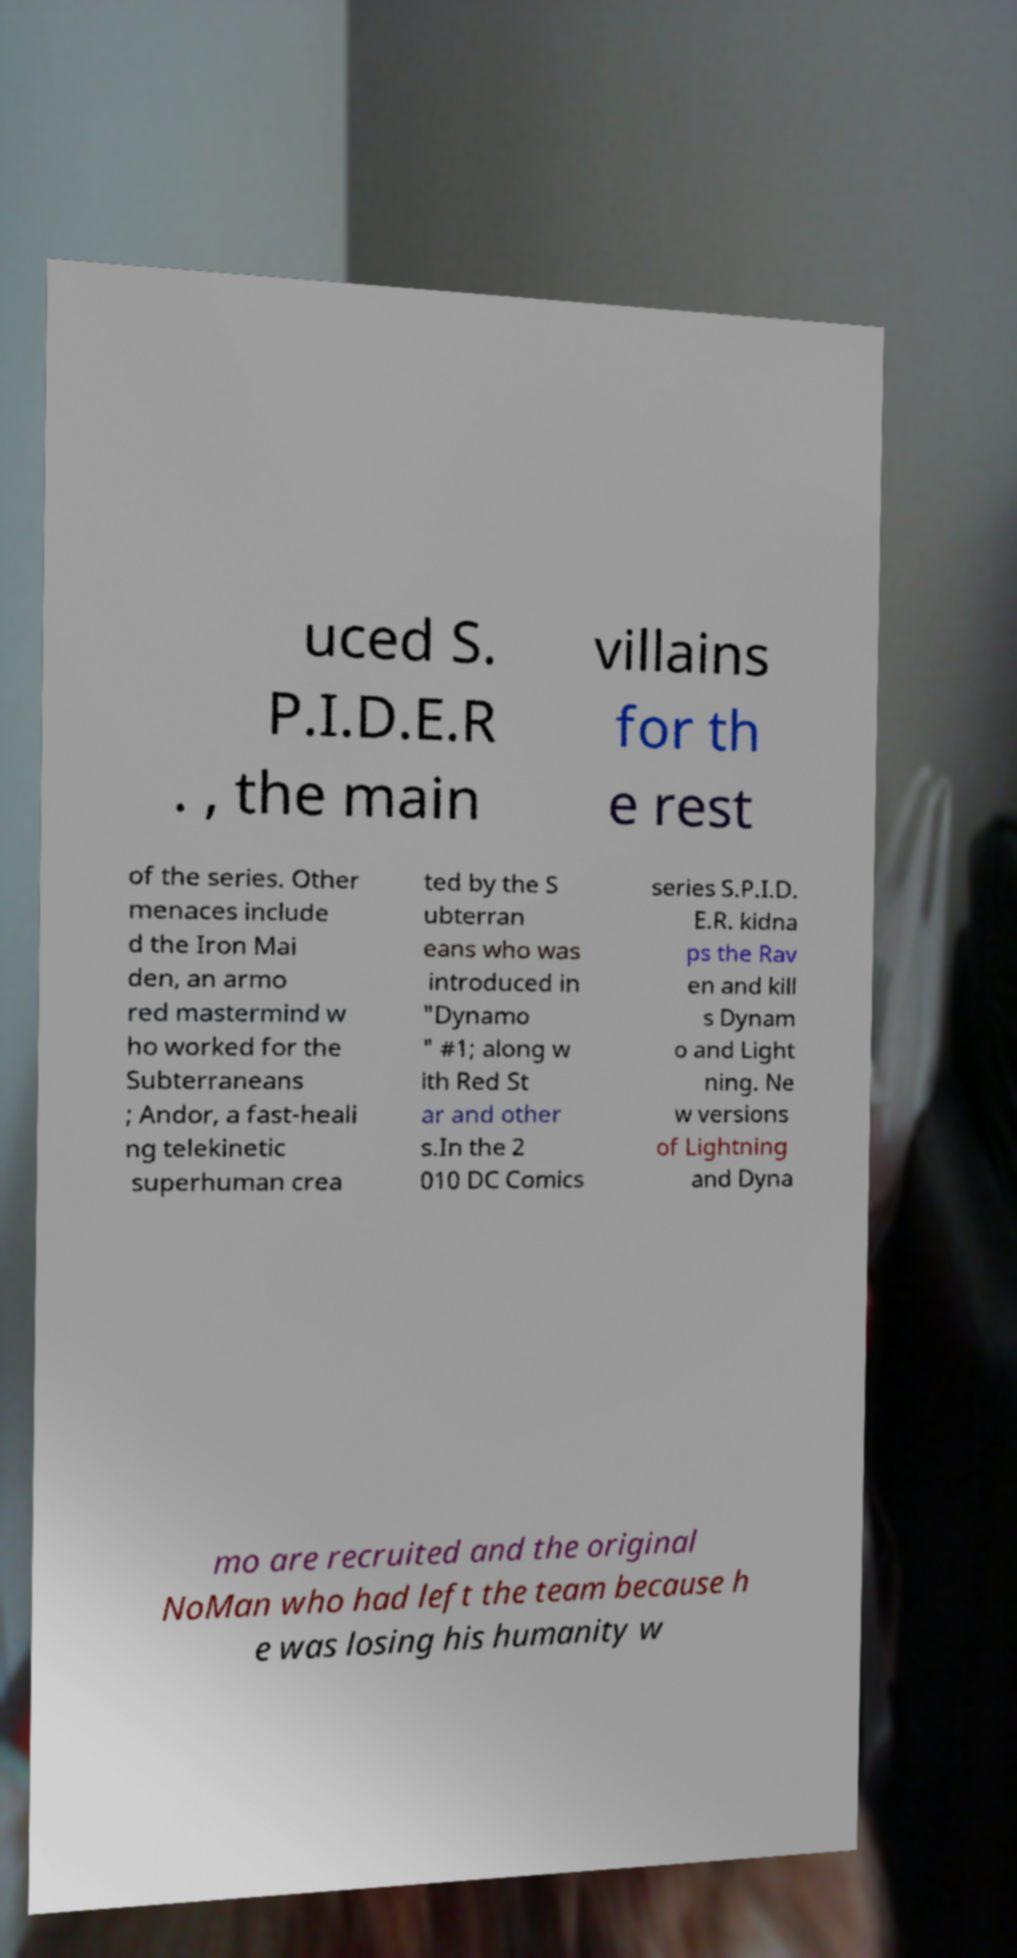I need the written content from this picture converted into text. Can you do that? uced S. P.I.D.E.R . , the main villains for th e rest of the series. Other menaces include d the Iron Mai den, an armo red mastermind w ho worked for the Subterraneans ; Andor, a fast-heali ng telekinetic superhuman crea ted by the S ubterran eans who was introduced in "Dynamo " #1; along w ith Red St ar and other s.In the 2 010 DC Comics series S.P.I.D. E.R. kidna ps the Rav en and kill s Dynam o and Light ning. Ne w versions of Lightning and Dyna mo are recruited and the original NoMan who had left the team because h e was losing his humanity w 